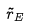<formula> <loc_0><loc_0><loc_500><loc_500>\tilde { r } _ { E }</formula> 